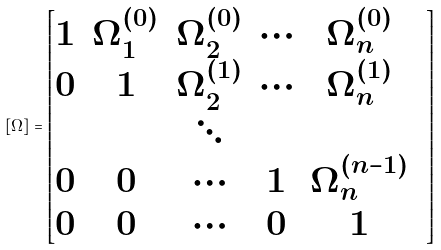Convert formula to latex. <formula><loc_0><loc_0><loc_500><loc_500>[ \Omega ] = \begin{bmatrix} 1 & \Omega _ { 1 } ^ { ( 0 ) } & \Omega _ { 2 } ^ { ( 0 ) } & \cdots & \Omega _ { n } ^ { ( 0 ) } \\ 0 & 1 & \Omega _ { 2 } ^ { ( 1 ) } & \cdots & \Omega _ { n } ^ { ( 1 ) } \\ & & \ddots & & & \\ 0 & 0 & \cdots & 1 & \Omega _ { n } ^ { ( n - 1 ) } \\ 0 & 0 & \cdots & 0 & 1 \end{bmatrix}</formula> 